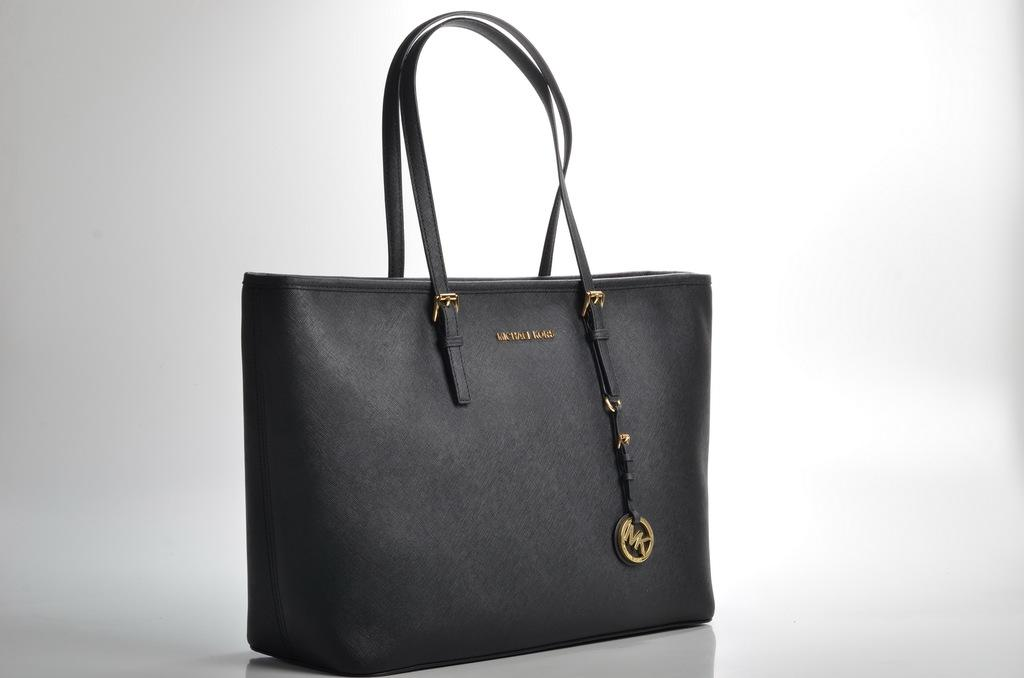What is the main subject of the image? The main subject of the image is a handbag. Can you describe the location of the handbag in the image? The handbag is in the center of the image. What color is the handbag? The handbag is black in color. What type of texture can be seen on the snail in the image? There is no snail present in the image, so it is not possible to determine the texture of a snail. 